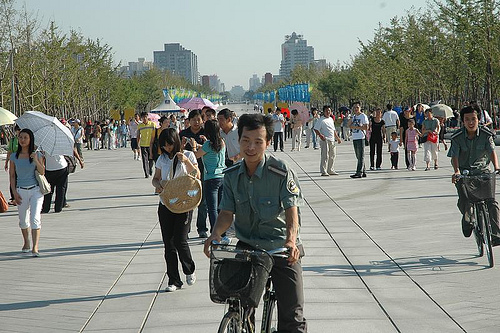<image>
Can you confirm if the woman is behind the tree? No. The woman is not behind the tree. From this viewpoint, the woman appears to be positioned elsewhere in the scene. Where is the woman in relation to the girl? Is it in front of the girl? No. The woman is not in front of the girl. The spatial positioning shows a different relationship between these objects. 